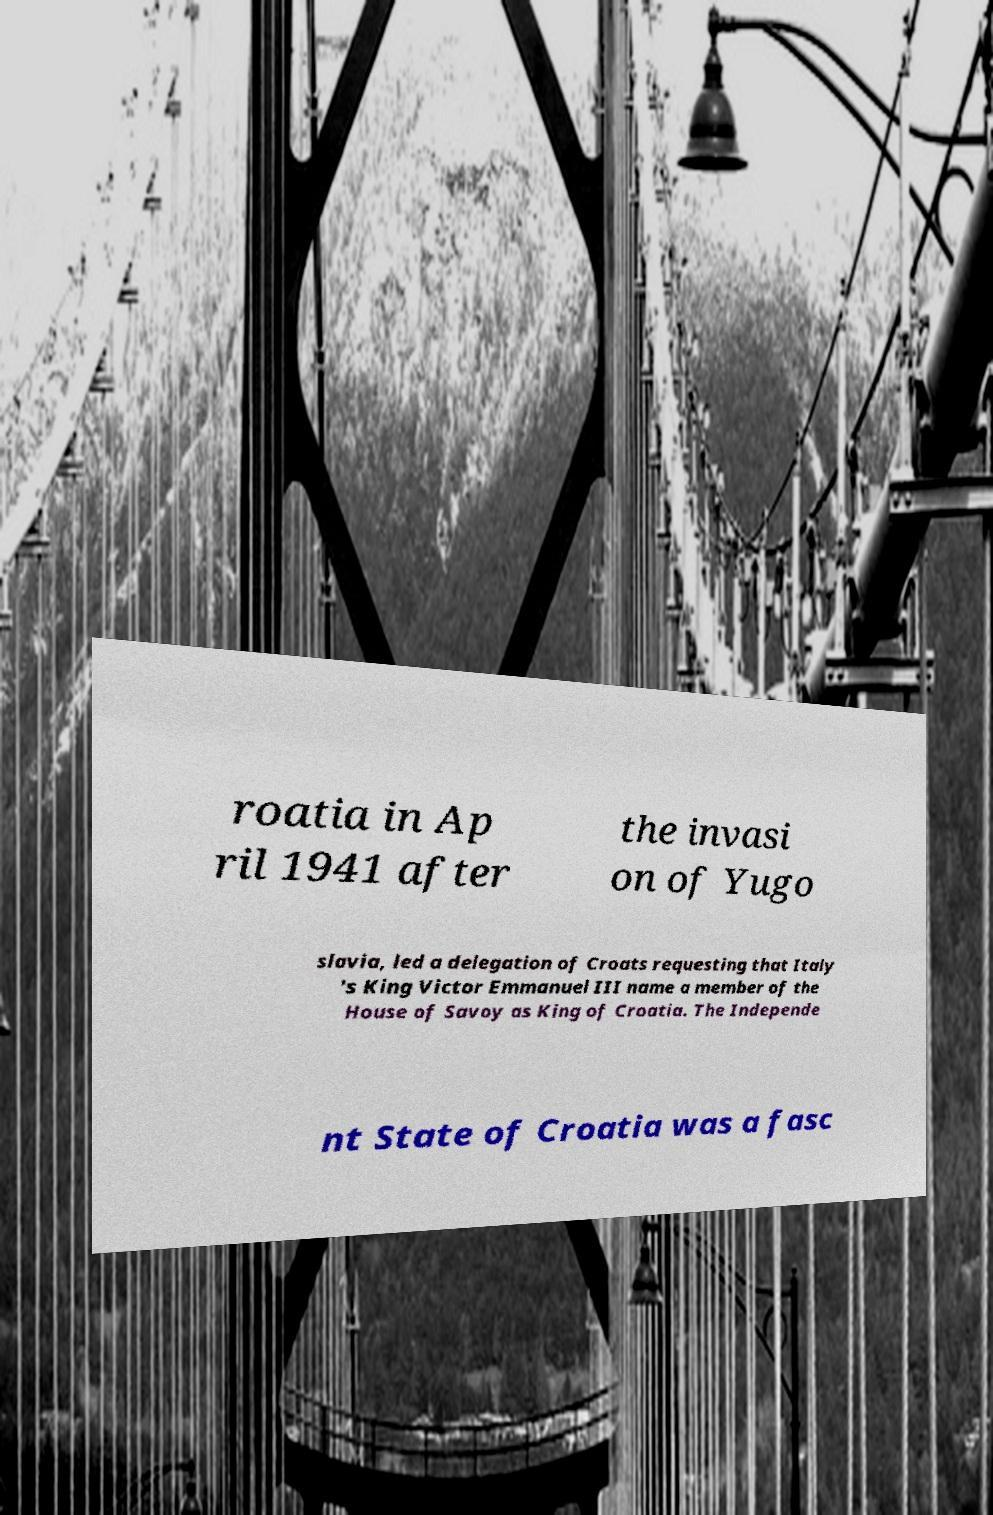Please read and relay the text visible in this image. What does it say? roatia in Ap ril 1941 after the invasi on of Yugo slavia, led a delegation of Croats requesting that Italy 's King Victor Emmanuel III name a member of the House of Savoy as King of Croatia. The Independe nt State of Croatia was a fasc 